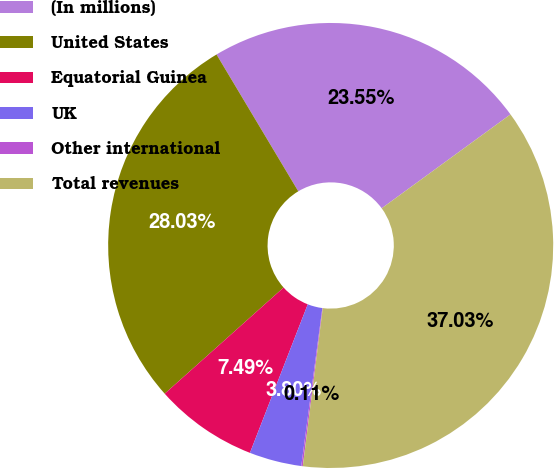<chart> <loc_0><loc_0><loc_500><loc_500><pie_chart><fcel>(In millions)<fcel>United States<fcel>Equatorial Guinea<fcel>UK<fcel>Other international<fcel>Total revenues<nl><fcel>23.55%<fcel>28.03%<fcel>7.49%<fcel>3.8%<fcel>0.11%<fcel>37.03%<nl></chart> 